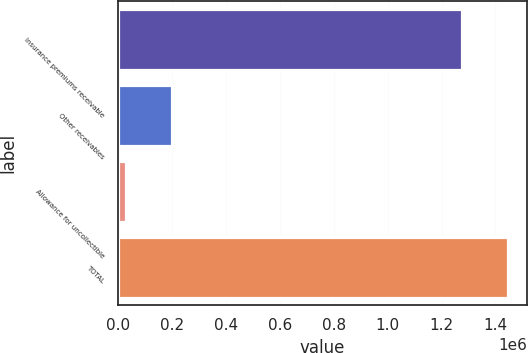Convert chart to OTSL. <chart><loc_0><loc_0><loc_500><loc_500><bar_chart><fcel>Insurance premiums receivable<fcel>Other receivables<fcel>Allowance for uncollectible<fcel>TOTAL<nl><fcel>1.27544e+06<fcel>201758<fcel>31568<fcel>1.44563e+06<nl></chart> 